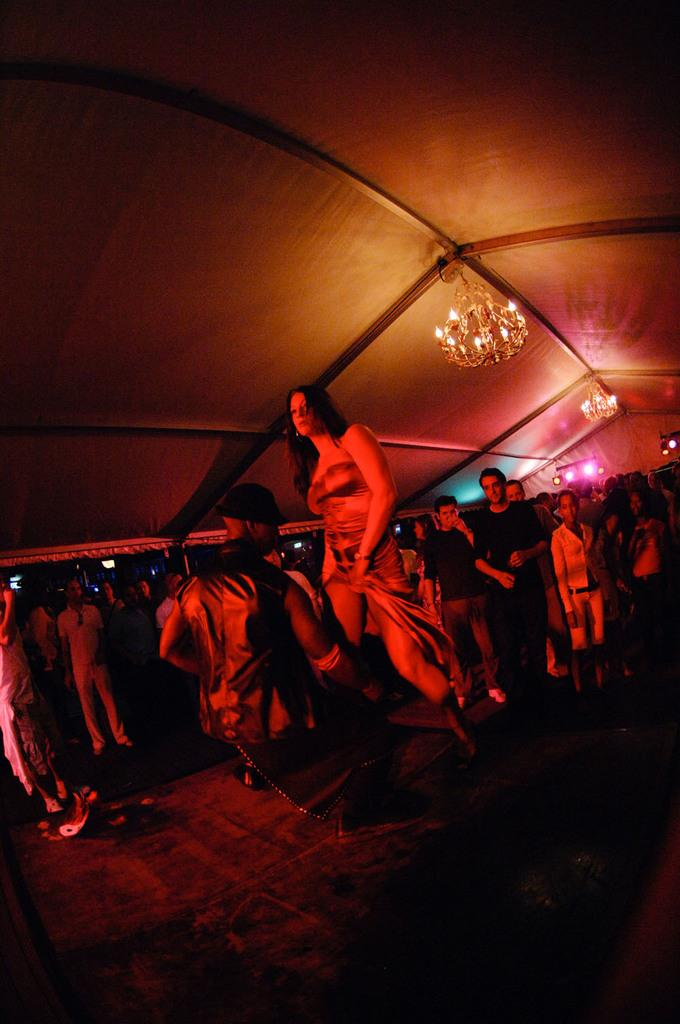What types of people are in the image? There are men and women in the image. What are the people doing in the image? The people are standing and walking on the land. What type of decorative lighting is present in the image? There are chandeliers in the image. Where are the chandeliers located in the image? The chandeliers are attached to the ceiling. What discovery was made by the legs in the image? There are no legs mentioned in the image, and therefore no discovery can be attributed to them. 